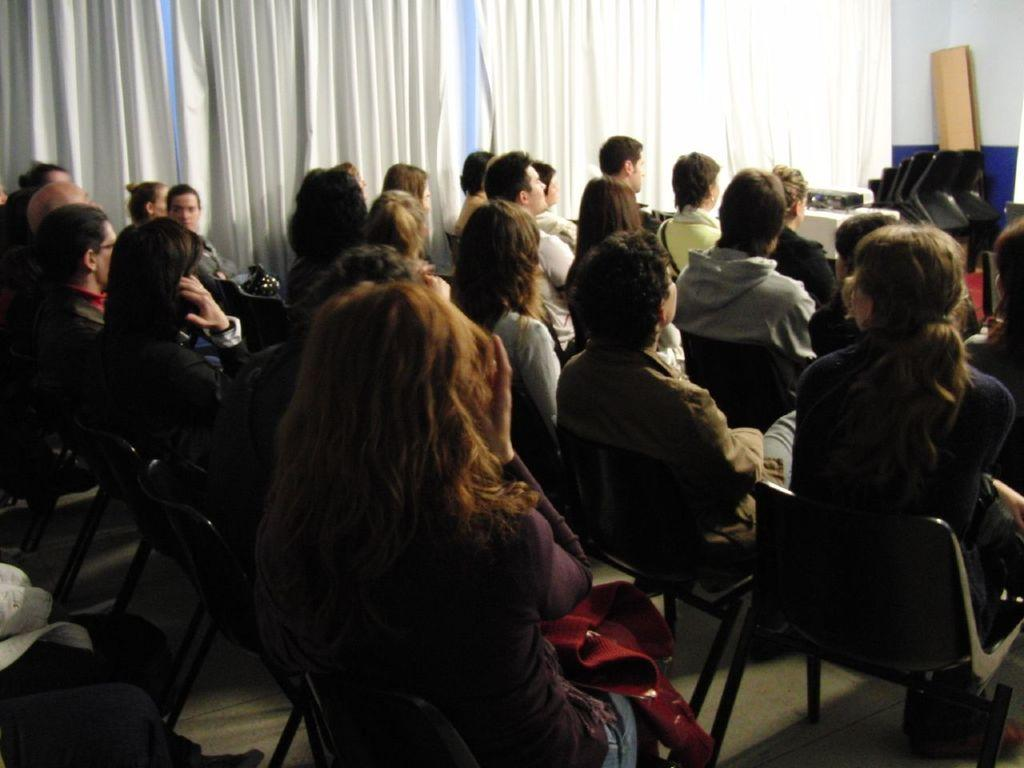How many persons are in the image? There is a group of persons in the image. What are the persons doing in the image? The persons are sitting in chairs. What can be seen in the background of the image? There is a curtain, a table, chairs, and a wall in the background of the image. What type of steam is coming out of the persons' ears in the image? There is no steam coming out of the persons' ears in the image. What type of transport is visible in the image? There is no transport visible in the image. 